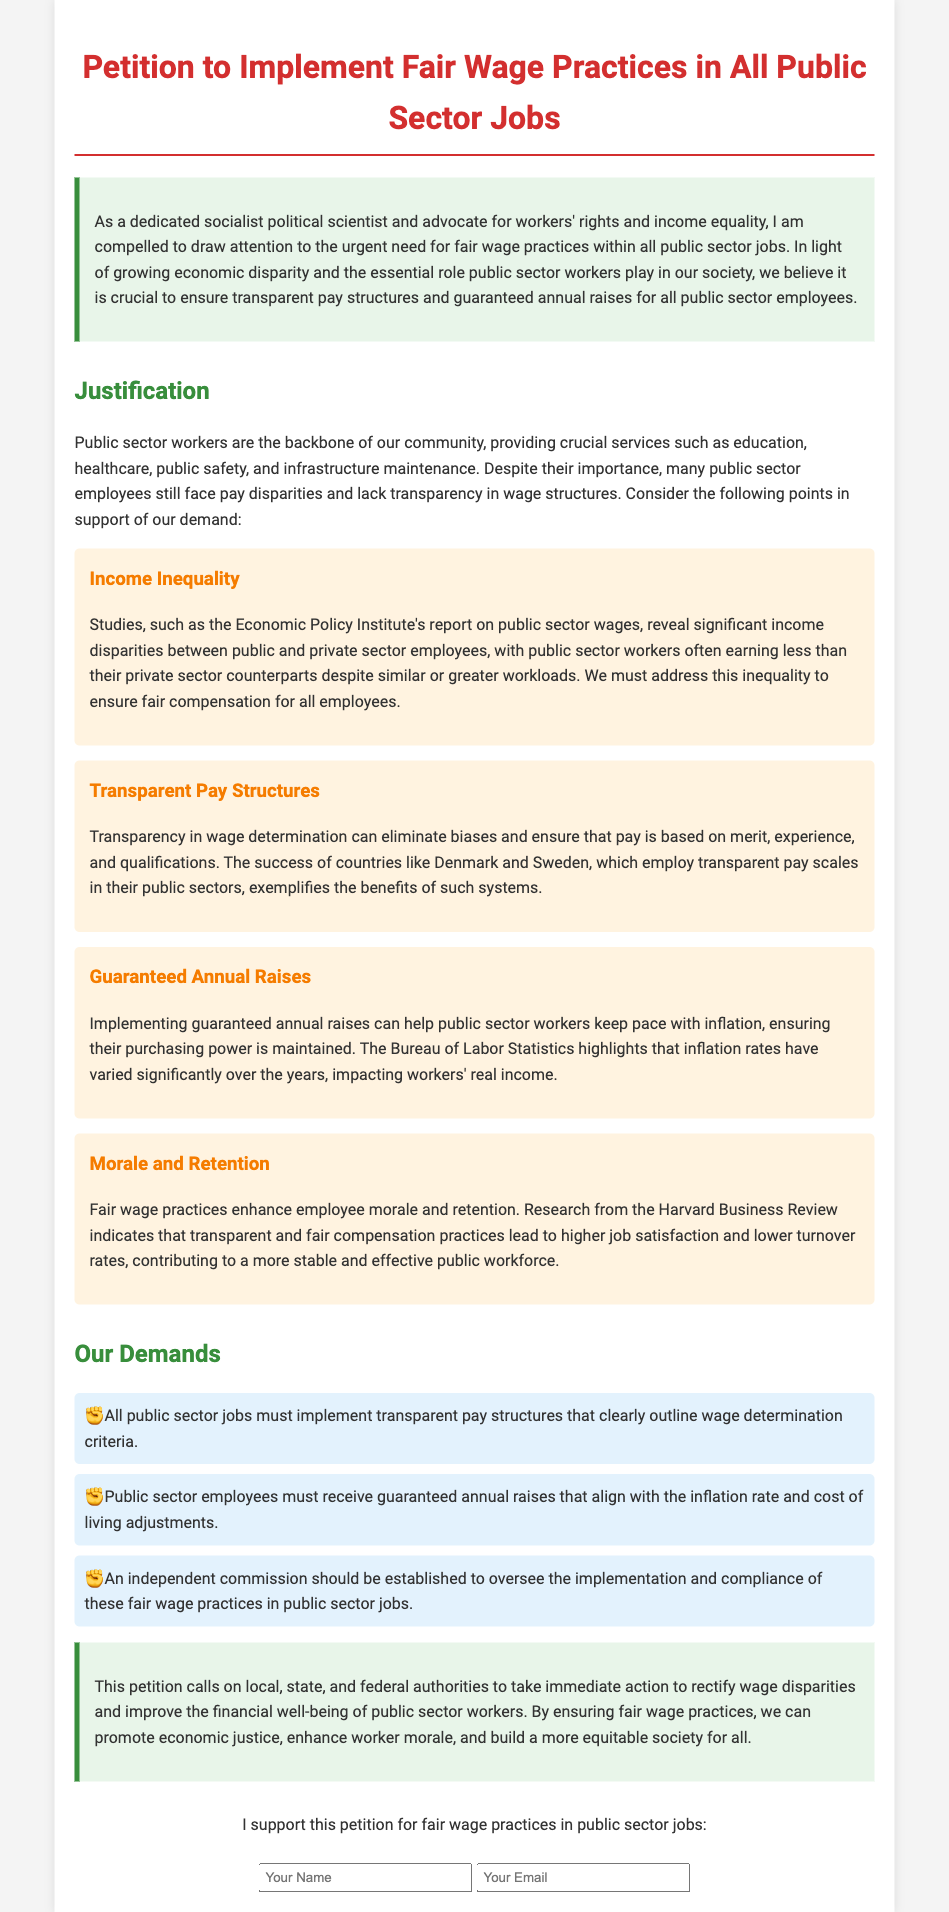What is the title of the petition? The title of the petition is specified at the top of the document.
Answer: Petition to Implement Fair Wage Practices in All Public Sector Jobs Who is the petition aimed at? The document calls on local, state, and federal authorities, indicating the target audience of the petition.
Answer: Local, state, and federal authorities What is one reason highlighted for the need for fair wage practices? The document lists several reasons in the justification section, including income inequality.
Answer: Income inequality What are the demands made in the petition? The document outlines specific changes desired, which are detailed in the 'Our Demands' section.
Answer: Implement transparent pay structures What is one benefit of implementing guaranteed annual raises? The text explains the positive impact of guaranteed annual raises on maintaining purchasing power against inflation.
Answer: Maintain purchasing power Which countries are mentioned as examples of successful transparent pay structures? The reasoning section provides examples from countries with effective wage transparency practices.
Answer: Denmark and Sweden What type of commission is proposed in the demands? The demands section calls for a specific body to oversee wage practices.
Answer: Independent commission What effect does fair wage practice have on employee morale? The document discusses how fair wages contribute to higher job satisfaction and lower turnover rates.
Answer: Higher job satisfaction 